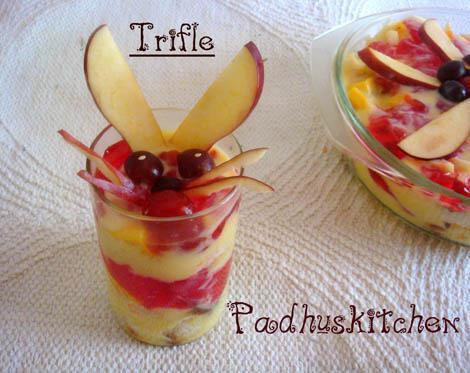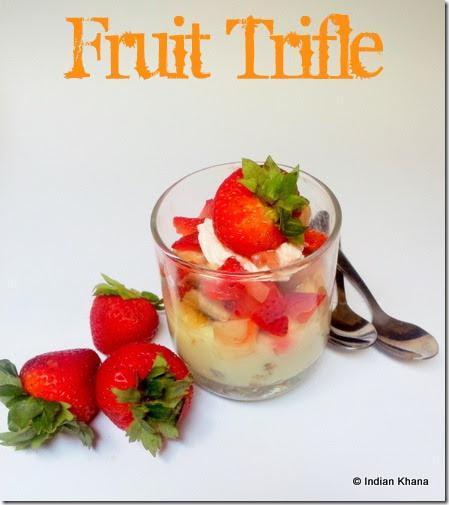The first image is the image on the left, the second image is the image on the right. Assess this claim about the two images: "An image shows spoons next to a trifle dessert.". Correct or not? Answer yes or no. Yes. 